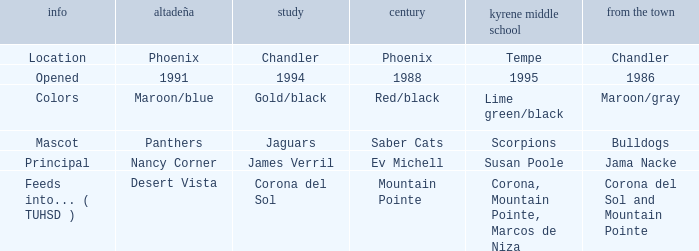Which Centennial has a Altadeña of panthers? Saber Cats. 